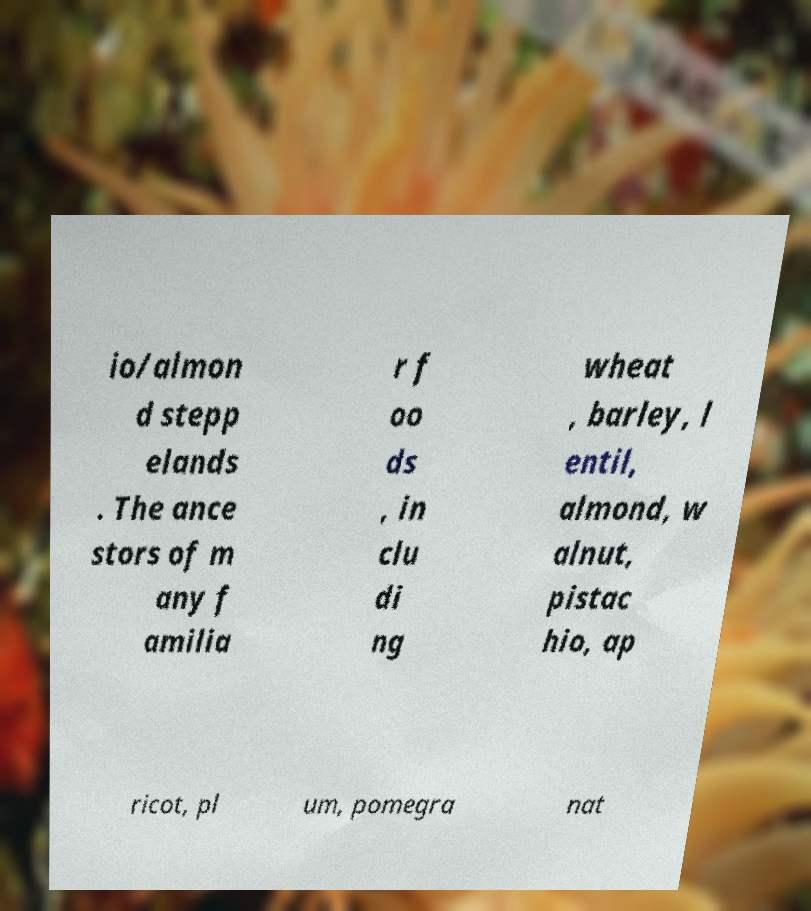There's text embedded in this image that I need extracted. Can you transcribe it verbatim? io/almon d stepp elands . The ance stors of m any f amilia r f oo ds , in clu di ng wheat , barley, l entil, almond, w alnut, pistac hio, ap ricot, pl um, pomegra nat 